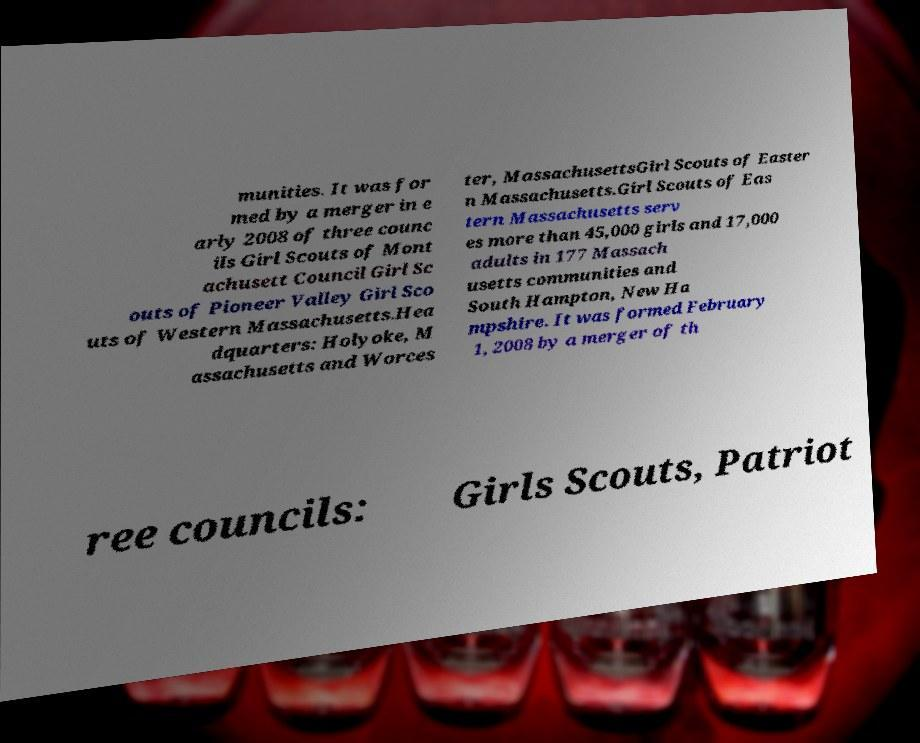Can you accurately transcribe the text from the provided image for me? munities. It was for med by a merger in e arly 2008 of three counc ils Girl Scouts of Mont achusett Council Girl Sc outs of Pioneer Valley Girl Sco uts of Western Massachusetts.Hea dquarters: Holyoke, M assachusetts and Worces ter, MassachusettsGirl Scouts of Easter n Massachusetts.Girl Scouts of Eas tern Massachusetts serv es more than 45,000 girls and 17,000 adults in 177 Massach usetts communities and South Hampton, New Ha mpshire. It was formed February 1, 2008 by a merger of th ree councils: Girls Scouts, Patriot 